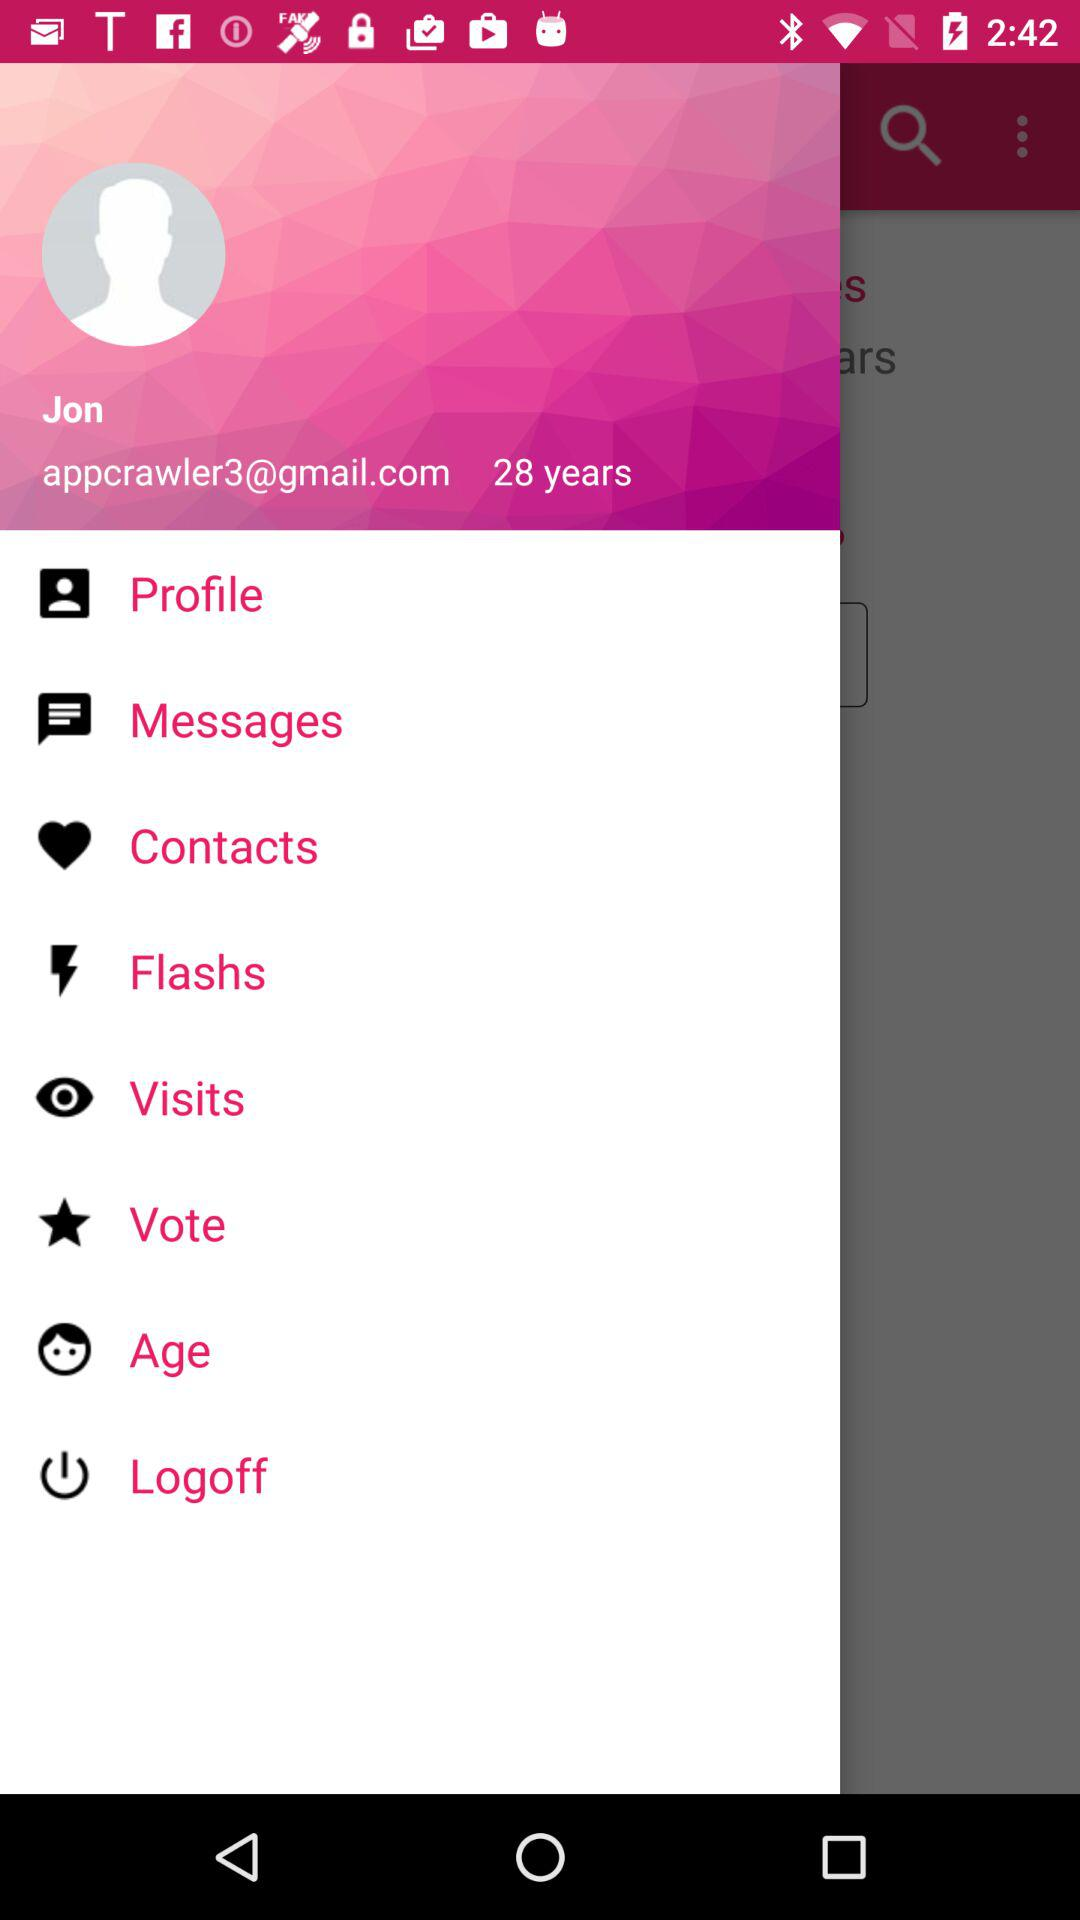What is the email ID of Jon? The email ID is appcrawler3@gmail.com. 